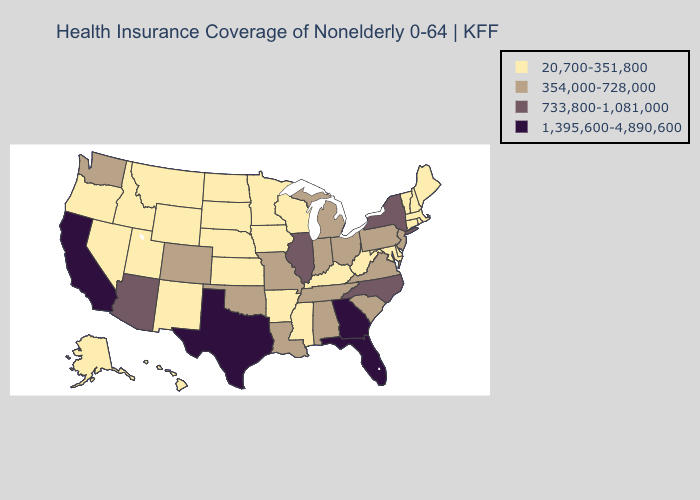Does New Jersey have the lowest value in the USA?
Answer briefly. No. What is the value of Iowa?
Write a very short answer. 20,700-351,800. What is the highest value in states that border Florida?
Keep it brief. 1,395,600-4,890,600. Name the states that have a value in the range 1,395,600-4,890,600?
Concise answer only. California, Florida, Georgia, Texas. Does the map have missing data?
Short answer required. No. Among the states that border West Virginia , does Ohio have the lowest value?
Answer briefly. No. Among the states that border Indiana , does Michigan have the lowest value?
Concise answer only. No. Does Vermont have the highest value in the USA?
Short answer required. No. What is the lowest value in the USA?
Be succinct. 20,700-351,800. Name the states that have a value in the range 733,800-1,081,000?
Write a very short answer. Arizona, Illinois, New York, North Carolina. What is the value of Massachusetts?
Keep it brief. 20,700-351,800. Does Pennsylvania have a higher value than Mississippi?
Short answer required. Yes. Is the legend a continuous bar?
Write a very short answer. No. Does the map have missing data?
Concise answer only. No. Which states have the lowest value in the West?
Give a very brief answer. Alaska, Hawaii, Idaho, Montana, Nevada, New Mexico, Oregon, Utah, Wyoming. 